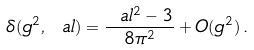<formula> <loc_0><loc_0><loc_500><loc_500>\delta ( g ^ { 2 } , \ a l ) = \frac { \ a l ^ { 2 } - 3 } { 8 \pi ^ { 2 } } + O ( g ^ { 2 } ) \, .</formula> 